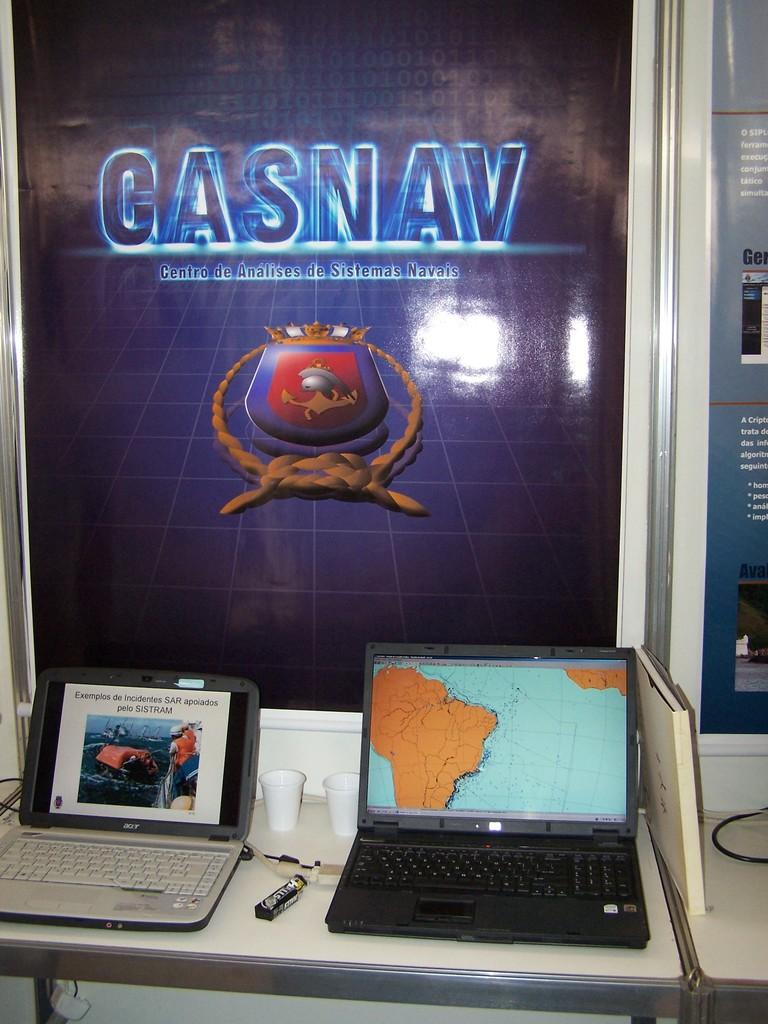What objects are located at the bottom of the image? There are laptops, chocolate, and glasses at the bottom of the image. Where are these objects placed? The objects are placed on a table. What can be seen in the background of the image? There is an advertisement and a wall in the background of the image. How many mines are visible in the image? There are no mines present in the image. Can you tell me how many volleyballs are on the table in the image? There is no volleyball present in the image. 